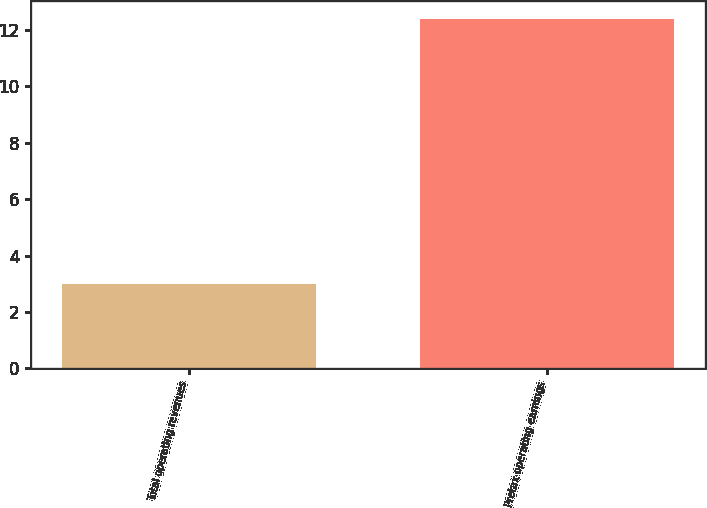Convert chart to OTSL. <chart><loc_0><loc_0><loc_500><loc_500><bar_chart><fcel>Total operating revenues<fcel>Pretax operating earnings<nl><fcel>3<fcel>12.4<nl></chart> 